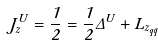<formula> <loc_0><loc_0><loc_500><loc_500>J ^ { U } _ { z } = \frac { 1 } { 2 } = \frac { 1 } { 2 } \Delta \Sigma ^ { U } + L _ { z _ { q \bar { q } } }</formula> 